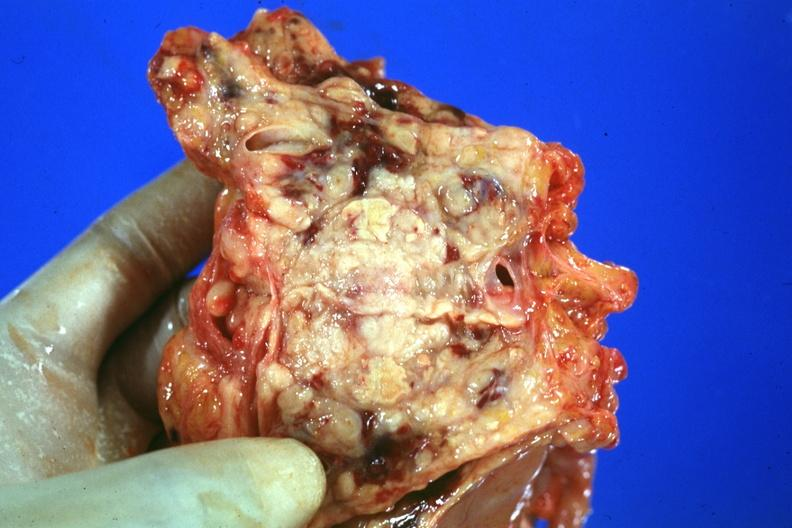what does this image show?
Answer the question using a single word or phrase. Prostate is cut open showing neoplasm quite good 